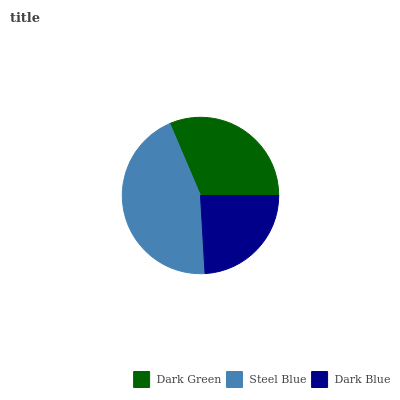Is Dark Blue the minimum?
Answer yes or no. Yes. Is Steel Blue the maximum?
Answer yes or no. Yes. Is Steel Blue the minimum?
Answer yes or no. No. Is Dark Blue the maximum?
Answer yes or no. No. Is Steel Blue greater than Dark Blue?
Answer yes or no. Yes. Is Dark Blue less than Steel Blue?
Answer yes or no. Yes. Is Dark Blue greater than Steel Blue?
Answer yes or no. No. Is Steel Blue less than Dark Blue?
Answer yes or no. No. Is Dark Green the high median?
Answer yes or no. Yes. Is Dark Green the low median?
Answer yes or no. Yes. Is Dark Blue the high median?
Answer yes or no. No. Is Steel Blue the low median?
Answer yes or no. No. 